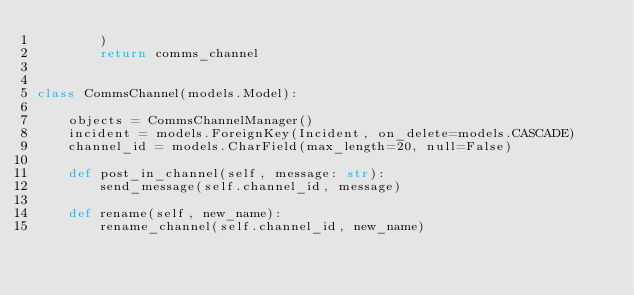<code> <loc_0><loc_0><loc_500><loc_500><_Python_>        )
        return comms_channel


class CommsChannel(models.Model):

    objects = CommsChannelManager()
    incident = models.ForeignKey(Incident, on_delete=models.CASCADE)
    channel_id = models.CharField(max_length=20, null=False)

    def post_in_channel(self, message: str):
        send_message(self.channel_id, message)

    def rename(self, new_name):
        rename_channel(self.channel_id, new_name)
</code> 